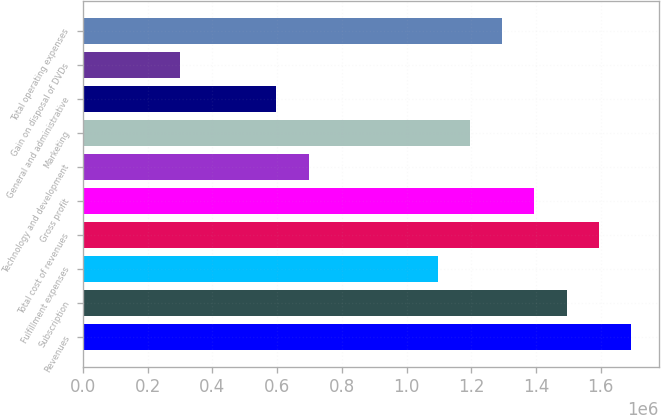<chart> <loc_0><loc_0><loc_500><loc_500><bar_chart><fcel>Revenues<fcel>Subscription<fcel>Fulfillment expenses<fcel>Total cost of revenues<fcel>Gross profit<fcel>Technology and development<fcel>Marketing<fcel>General and administrative<fcel>Gain on disposal of DVDs<fcel>Total operating expenses<nl><fcel>1.69432e+06<fcel>1.49499e+06<fcel>1.09633e+06<fcel>1.59466e+06<fcel>1.39532e+06<fcel>697662<fcel>1.19599e+06<fcel>597996<fcel>298998<fcel>1.29566e+06<nl></chart> 